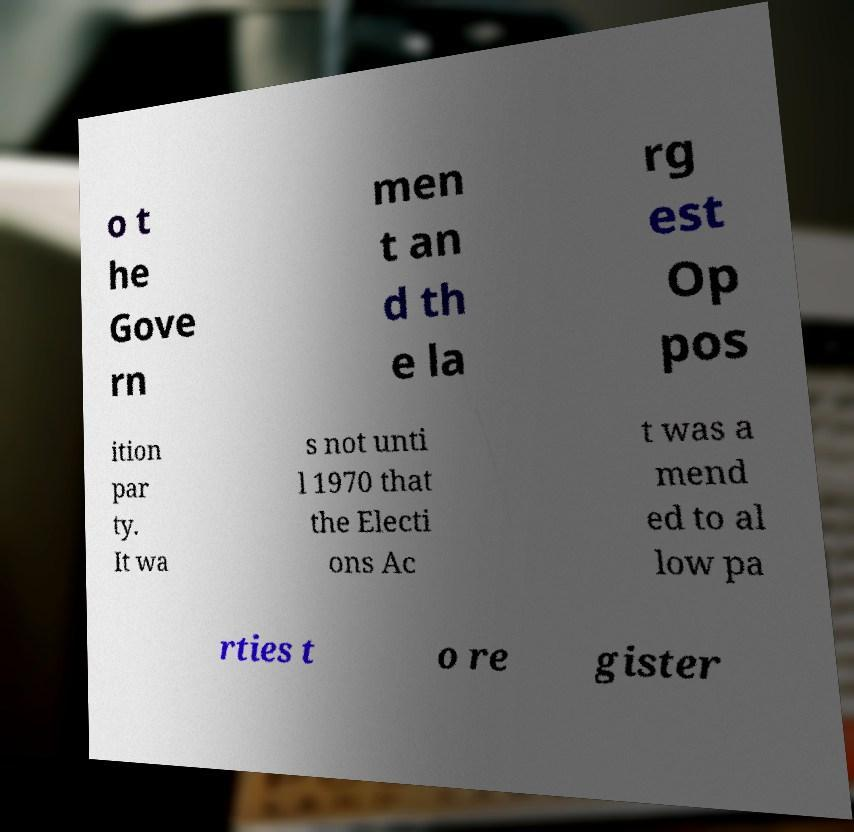I need the written content from this picture converted into text. Can you do that? o t he Gove rn men t an d th e la rg est Op pos ition par ty. It wa s not unti l 1970 that the Electi ons Ac t was a mend ed to al low pa rties t o re gister 